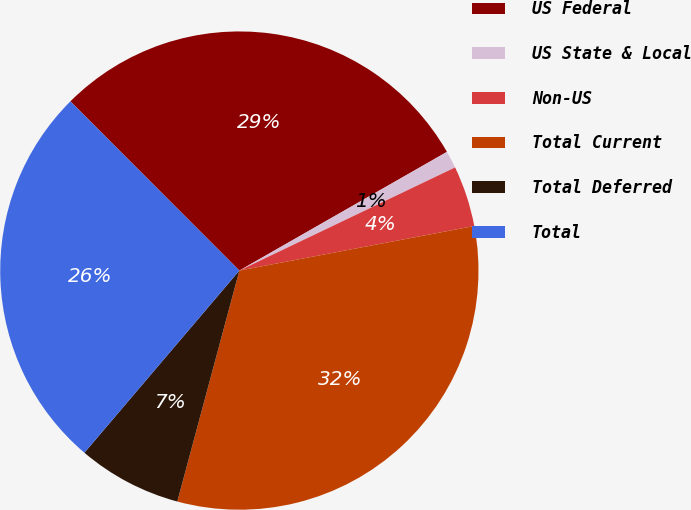Convert chart. <chart><loc_0><loc_0><loc_500><loc_500><pie_chart><fcel>US Federal<fcel>US State & Local<fcel>Non-US<fcel>Total Current<fcel>Total Deferred<fcel>Total<nl><fcel>29.22%<fcel>1.17%<fcel>4.11%<fcel>32.16%<fcel>7.04%<fcel>26.29%<nl></chart> 